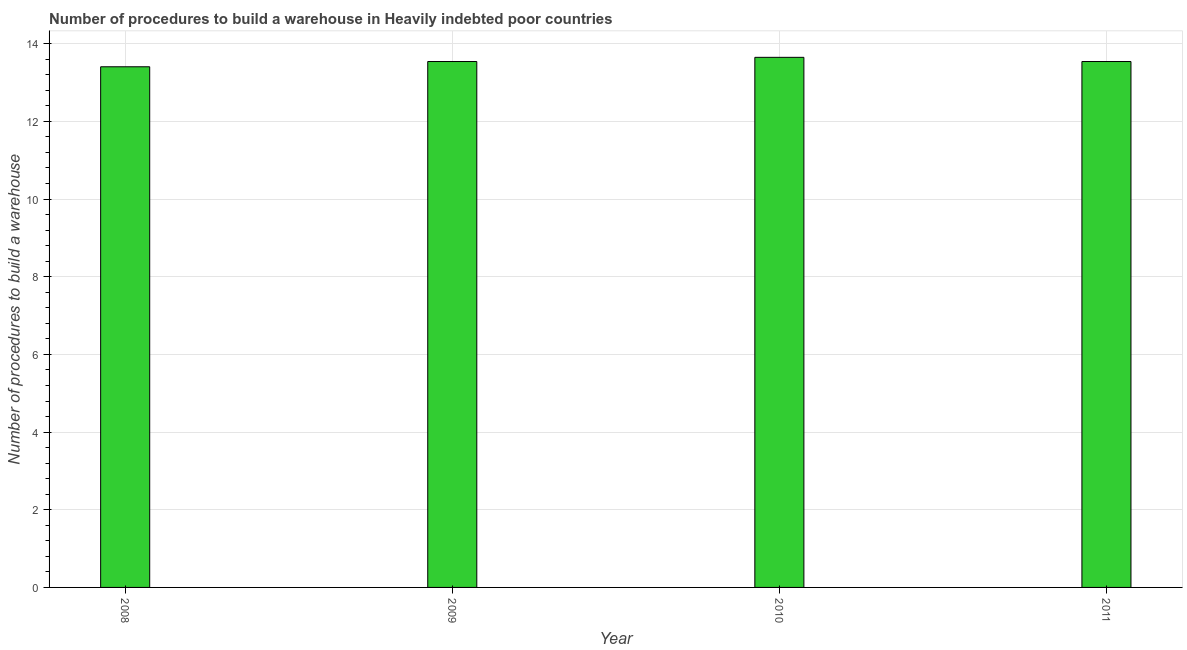What is the title of the graph?
Your answer should be compact. Number of procedures to build a warehouse in Heavily indebted poor countries. What is the label or title of the Y-axis?
Your answer should be compact. Number of procedures to build a warehouse. What is the number of procedures to build a warehouse in 2008?
Ensure brevity in your answer.  13.41. Across all years, what is the maximum number of procedures to build a warehouse?
Give a very brief answer. 13.65. Across all years, what is the minimum number of procedures to build a warehouse?
Make the answer very short. 13.41. In which year was the number of procedures to build a warehouse maximum?
Provide a short and direct response. 2010. What is the sum of the number of procedures to build a warehouse?
Your answer should be very brief. 54.14. What is the average number of procedures to build a warehouse per year?
Keep it short and to the point. 13.53. What is the median number of procedures to build a warehouse?
Offer a very short reply. 13.54. Do a majority of the years between 2009 and 2011 (inclusive) have number of procedures to build a warehouse greater than 6.8 ?
Offer a very short reply. Yes. Is the number of procedures to build a warehouse in 2009 less than that in 2010?
Offer a very short reply. Yes. Is the difference between the number of procedures to build a warehouse in 2009 and 2010 greater than the difference between any two years?
Make the answer very short. No. What is the difference between the highest and the second highest number of procedures to build a warehouse?
Your answer should be very brief. 0.11. Is the sum of the number of procedures to build a warehouse in 2009 and 2010 greater than the maximum number of procedures to build a warehouse across all years?
Ensure brevity in your answer.  Yes. What is the difference between the highest and the lowest number of procedures to build a warehouse?
Your response must be concise. 0.24. Are all the bars in the graph horizontal?
Your response must be concise. No. How many years are there in the graph?
Your answer should be compact. 4. What is the difference between two consecutive major ticks on the Y-axis?
Your response must be concise. 2. What is the Number of procedures to build a warehouse of 2008?
Your response must be concise. 13.41. What is the Number of procedures to build a warehouse in 2009?
Your response must be concise. 13.54. What is the Number of procedures to build a warehouse in 2010?
Offer a terse response. 13.65. What is the Number of procedures to build a warehouse of 2011?
Make the answer very short. 13.54. What is the difference between the Number of procedures to build a warehouse in 2008 and 2009?
Ensure brevity in your answer.  -0.14. What is the difference between the Number of procedures to build a warehouse in 2008 and 2010?
Make the answer very short. -0.24. What is the difference between the Number of procedures to build a warehouse in 2008 and 2011?
Your response must be concise. -0.14. What is the difference between the Number of procedures to build a warehouse in 2009 and 2010?
Make the answer very short. -0.11. What is the difference between the Number of procedures to build a warehouse in 2009 and 2011?
Keep it short and to the point. 0. What is the difference between the Number of procedures to build a warehouse in 2010 and 2011?
Offer a terse response. 0.11. What is the ratio of the Number of procedures to build a warehouse in 2008 to that in 2009?
Make the answer very short. 0.99. What is the ratio of the Number of procedures to build a warehouse in 2008 to that in 2011?
Keep it short and to the point. 0.99. What is the ratio of the Number of procedures to build a warehouse in 2009 to that in 2010?
Provide a short and direct response. 0.99. What is the ratio of the Number of procedures to build a warehouse in 2010 to that in 2011?
Your response must be concise. 1.01. 